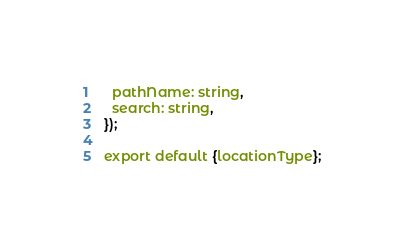Convert code to text. <code><loc_0><loc_0><loc_500><loc_500><_JavaScript_>  pathName: string,
  search: string,
});

export default {locationType};

</code> 